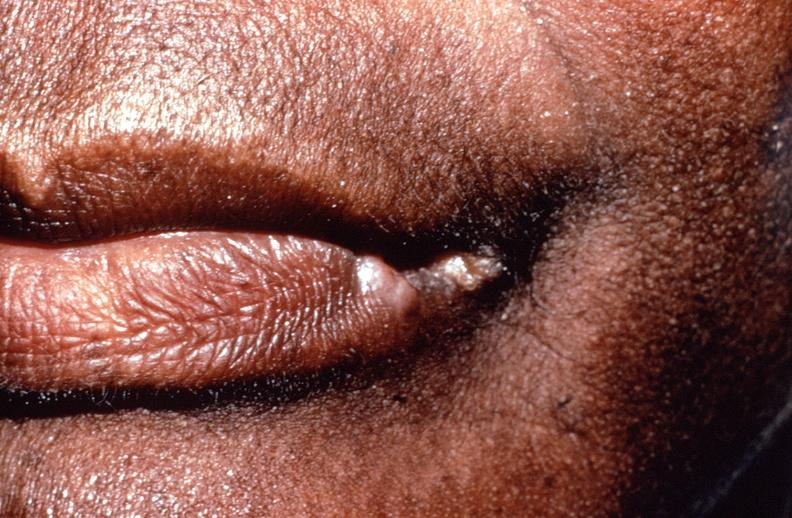what does this image show?
Answer the question using a single word or phrase. Squamous cell carcinoma 